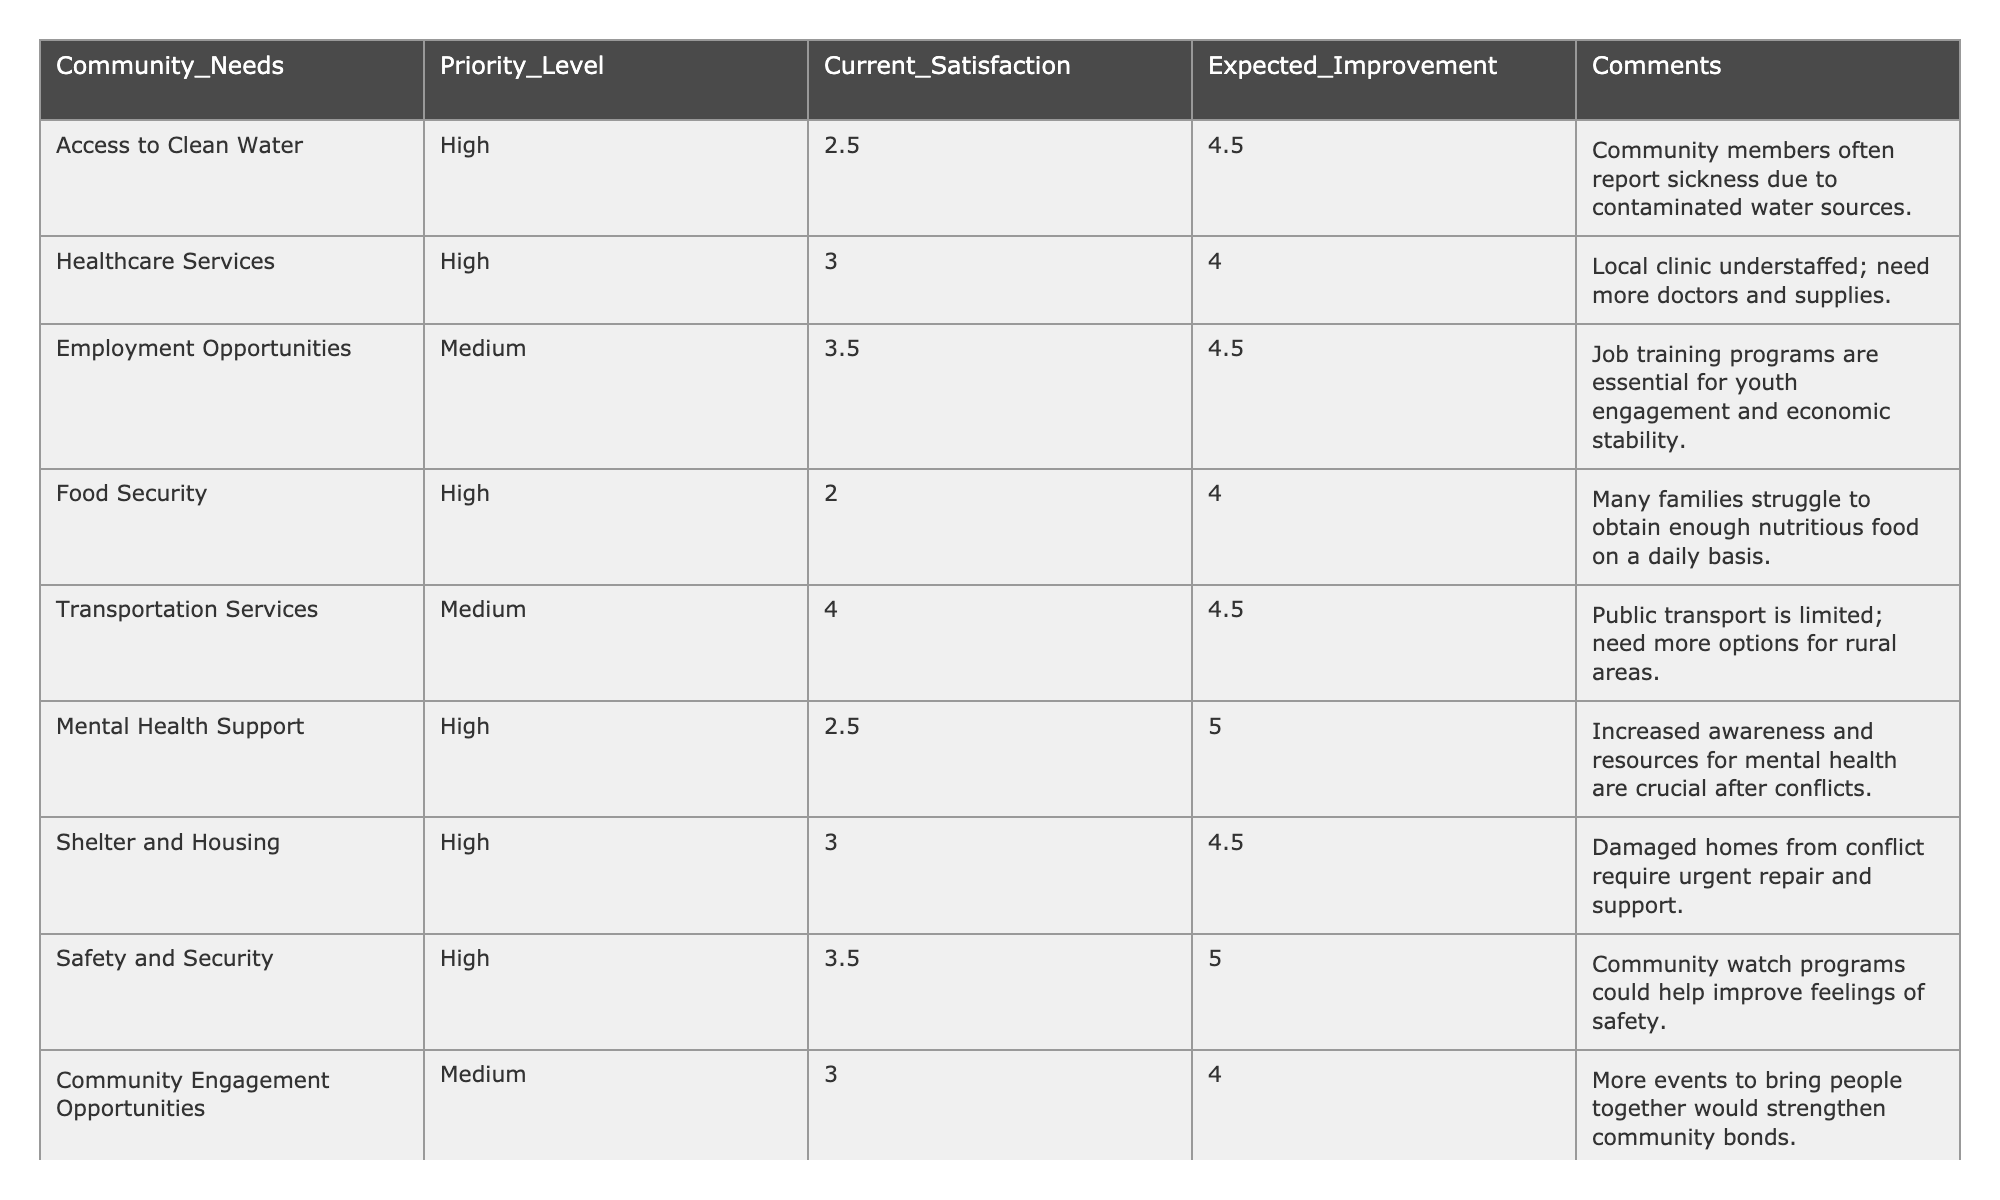What is the priority level for Access to Clean Water? The priority level column directly shows that Access to Clean Water has a "High" priority level.
Answer: High What is the current satisfaction rating for Food Security? Looking at the current satisfaction column, Food Security has a rating of 2.0.
Answer: 2.0 How many community needs have a high priority? Count the number of needs with a "High" priority level: Access to Clean Water, Healthcare Services, Food Security, Mental Health Support, Shelter and Housing, Safety and Security. This totals 6 needs.
Answer: 6 What is the expected improvement for Transportation Services? The expected improvement column indicates that Transportation Services has a rating of 4.5.
Answer: 4.5 Is the current satisfaction rating for Mental Health Support higher than for Shelter and Housing? The current satisfaction for Mental Health Support is 2.5 and for Shelter and Housing it is 3.0. Since 2.5 is less than 3.0, the statement is false.
Answer: False What is the average current satisfaction rating across all community needs? The current satisfaction ratings are 2.5, 3.0, 3.5, 2.0, 4.0, 2.5, 3.0, 3.5, and 3.0. Adding them gives 24.0 and dividing by the 9 needs gives an average of 24.0 / 9 = 2.67.
Answer: 2.67 Which need has the highest expected improvement? The expected improvement for Mental Health Support is 5.0, which is higher than any other need listed.
Answer: Mental Health Support What is the difference between current satisfaction and expected improvement for Food Security? Current satisfaction for Food Security is 2.0, and expected improvement is 4.0. The difference is 4.0 - 2.0 = 2.0.
Answer: 2.0 Is there a community need that does not have a high priority level? Employment Opportunities and Transportation Services both show a "Medium" priority level, so yes, there are needs with lower priority.
Answer: Yes Which need requires the most urgent attention based on current satisfaction ratings? Comparing current satisfaction ratings, Food Security has the lowest satisfaction at 2.0, indicating the greatest urgency for attention.
Answer: Food Security 